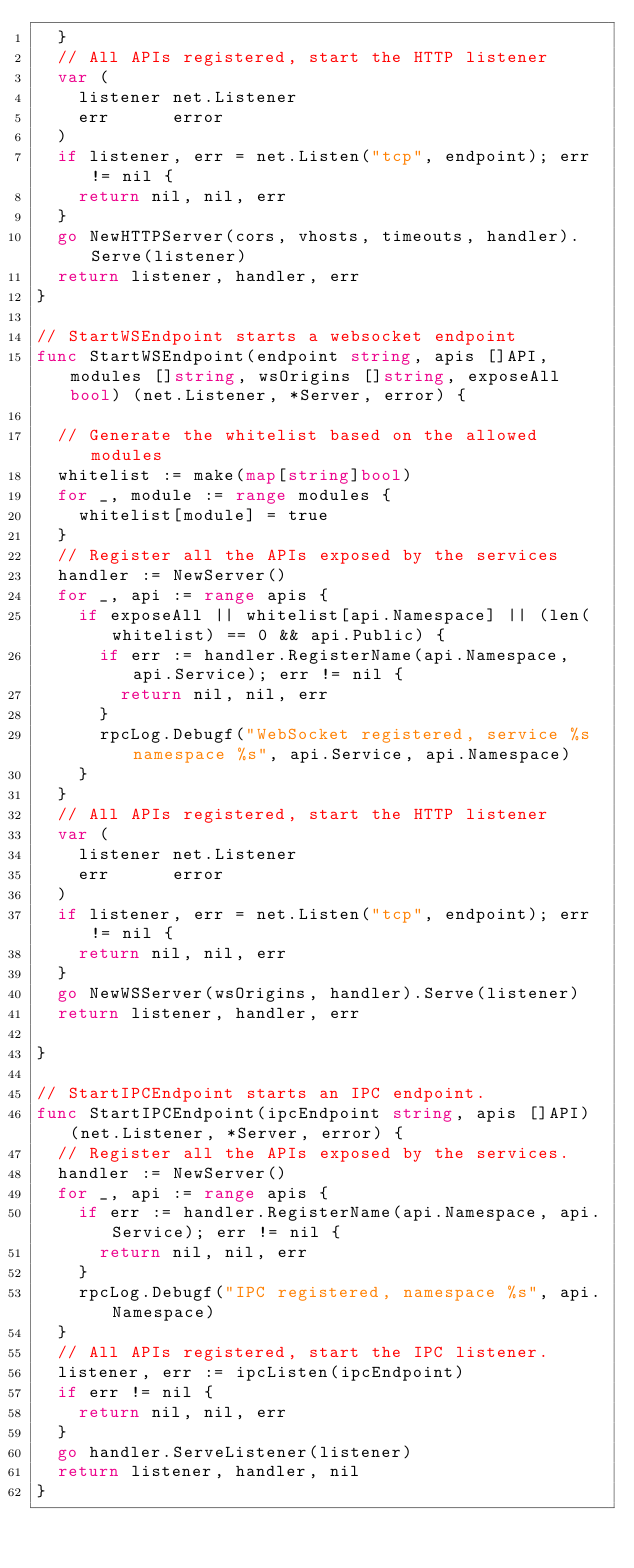<code> <loc_0><loc_0><loc_500><loc_500><_Go_>	}
	// All APIs registered, start the HTTP listener
	var (
		listener net.Listener
		err      error
	)
	if listener, err = net.Listen("tcp", endpoint); err != nil {
		return nil, nil, err
	}
	go NewHTTPServer(cors, vhosts, timeouts, handler).Serve(listener)
	return listener, handler, err
}

// StartWSEndpoint starts a websocket endpoint
func StartWSEndpoint(endpoint string, apis []API, modules []string, wsOrigins []string, exposeAll bool) (net.Listener, *Server, error) {

	// Generate the whitelist based on the allowed modules
	whitelist := make(map[string]bool)
	for _, module := range modules {
		whitelist[module] = true
	}
	// Register all the APIs exposed by the services
	handler := NewServer()
	for _, api := range apis {
		if exposeAll || whitelist[api.Namespace] || (len(whitelist) == 0 && api.Public) {
			if err := handler.RegisterName(api.Namespace, api.Service); err != nil {
				return nil, nil, err
			}
			rpcLog.Debugf("WebSocket registered, service %s namespace %s", api.Service, api.Namespace)
		}
	}
	// All APIs registered, start the HTTP listener
	var (
		listener net.Listener
		err      error
	)
	if listener, err = net.Listen("tcp", endpoint); err != nil {
		return nil, nil, err
	}
	go NewWSServer(wsOrigins, handler).Serve(listener)
	return listener, handler, err

}

// StartIPCEndpoint starts an IPC endpoint.
func StartIPCEndpoint(ipcEndpoint string, apis []API) (net.Listener, *Server, error) {
	// Register all the APIs exposed by the services.
	handler := NewServer()
	for _, api := range apis {
		if err := handler.RegisterName(api.Namespace, api.Service); err != nil {
			return nil, nil, err
		}
		rpcLog.Debugf("IPC registered, namespace %s", api.Namespace)
	}
	// All APIs registered, start the IPC listener.
	listener, err := ipcListen(ipcEndpoint)
	if err != nil {
		return nil, nil, err
	}
	go handler.ServeListener(listener)
	return listener, handler, nil
}
</code> 